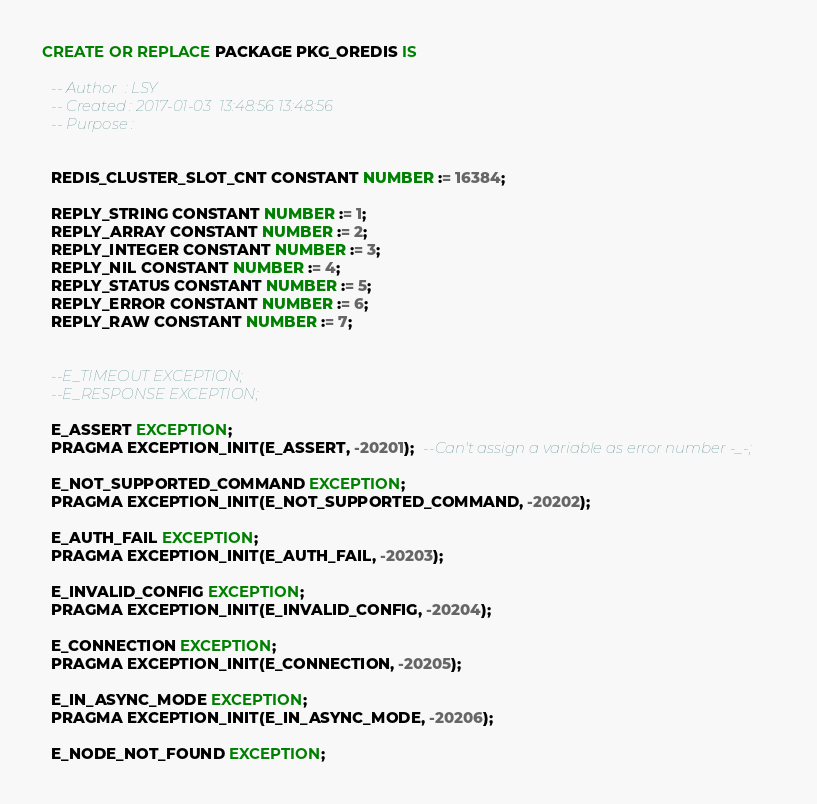<code> <loc_0><loc_0><loc_500><loc_500><_SQL_>CREATE OR REPLACE PACKAGE PKG_OREDIS IS

  -- Author  : LSY
  -- Created : 2017-01-03  13:48:56 13:48:56
  -- Purpose : 
    
  
  REDIS_CLUSTER_SLOT_CNT CONSTANT NUMBER := 16384;
  
  REPLY_STRING CONSTANT NUMBER := 1; 
  REPLY_ARRAY CONSTANT NUMBER := 2;     
  REPLY_INTEGER CONSTANT NUMBER := 3;
  REPLY_NIL CONSTANT NUMBER := 4;     
  REPLY_STATUS CONSTANT NUMBER := 5;
  REPLY_ERROR CONSTANT NUMBER := 6;
  REPLY_RAW CONSTANT NUMBER := 7;
    
  
  --E_TIMEOUT EXCEPTION;  
  --E_RESPONSE EXCEPTION;
  
  E_ASSERT EXCEPTION;
  PRAGMA EXCEPTION_INIT(E_ASSERT, -20201);  --Can't assign a variable as error number -_-;
  
  E_NOT_SUPPORTED_COMMAND EXCEPTION;
  PRAGMA EXCEPTION_INIT(E_NOT_SUPPORTED_COMMAND, -20202);
  
  E_AUTH_FAIL EXCEPTION;
  PRAGMA EXCEPTION_INIT(E_AUTH_FAIL, -20203);  
  
  E_INVALID_CONFIG EXCEPTION;
  PRAGMA EXCEPTION_INIT(E_INVALID_CONFIG, -20204);
  
  E_CONNECTION EXCEPTION;
  PRAGMA EXCEPTION_INIT(E_CONNECTION, -20205);
  
  E_IN_ASYNC_MODE EXCEPTION;
  PRAGMA EXCEPTION_INIT(E_IN_ASYNC_MODE, -20206);
  
  E_NODE_NOT_FOUND EXCEPTION;</code> 